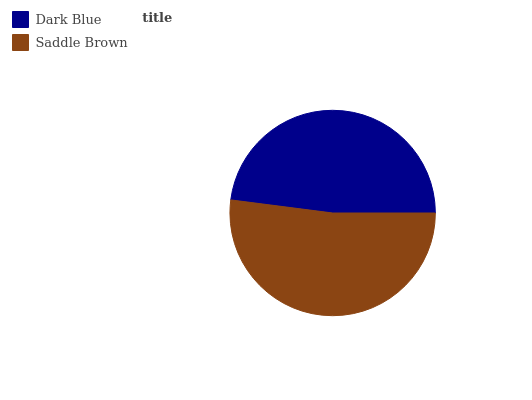Is Dark Blue the minimum?
Answer yes or no. Yes. Is Saddle Brown the maximum?
Answer yes or no. Yes. Is Saddle Brown the minimum?
Answer yes or no. No. Is Saddle Brown greater than Dark Blue?
Answer yes or no. Yes. Is Dark Blue less than Saddle Brown?
Answer yes or no. Yes. Is Dark Blue greater than Saddle Brown?
Answer yes or no. No. Is Saddle Brown less than Dark Blue?
Answer yes or no. No. Is Saddle Brown the high median?
Answer yes or no. Yes. Is Dark Blue the low median?
Answer yes or no. Yes. Is Dark Blue the high median?
Answer yes or no. No. Is Saddle Brown the low median?
Answer yes or no. No. 